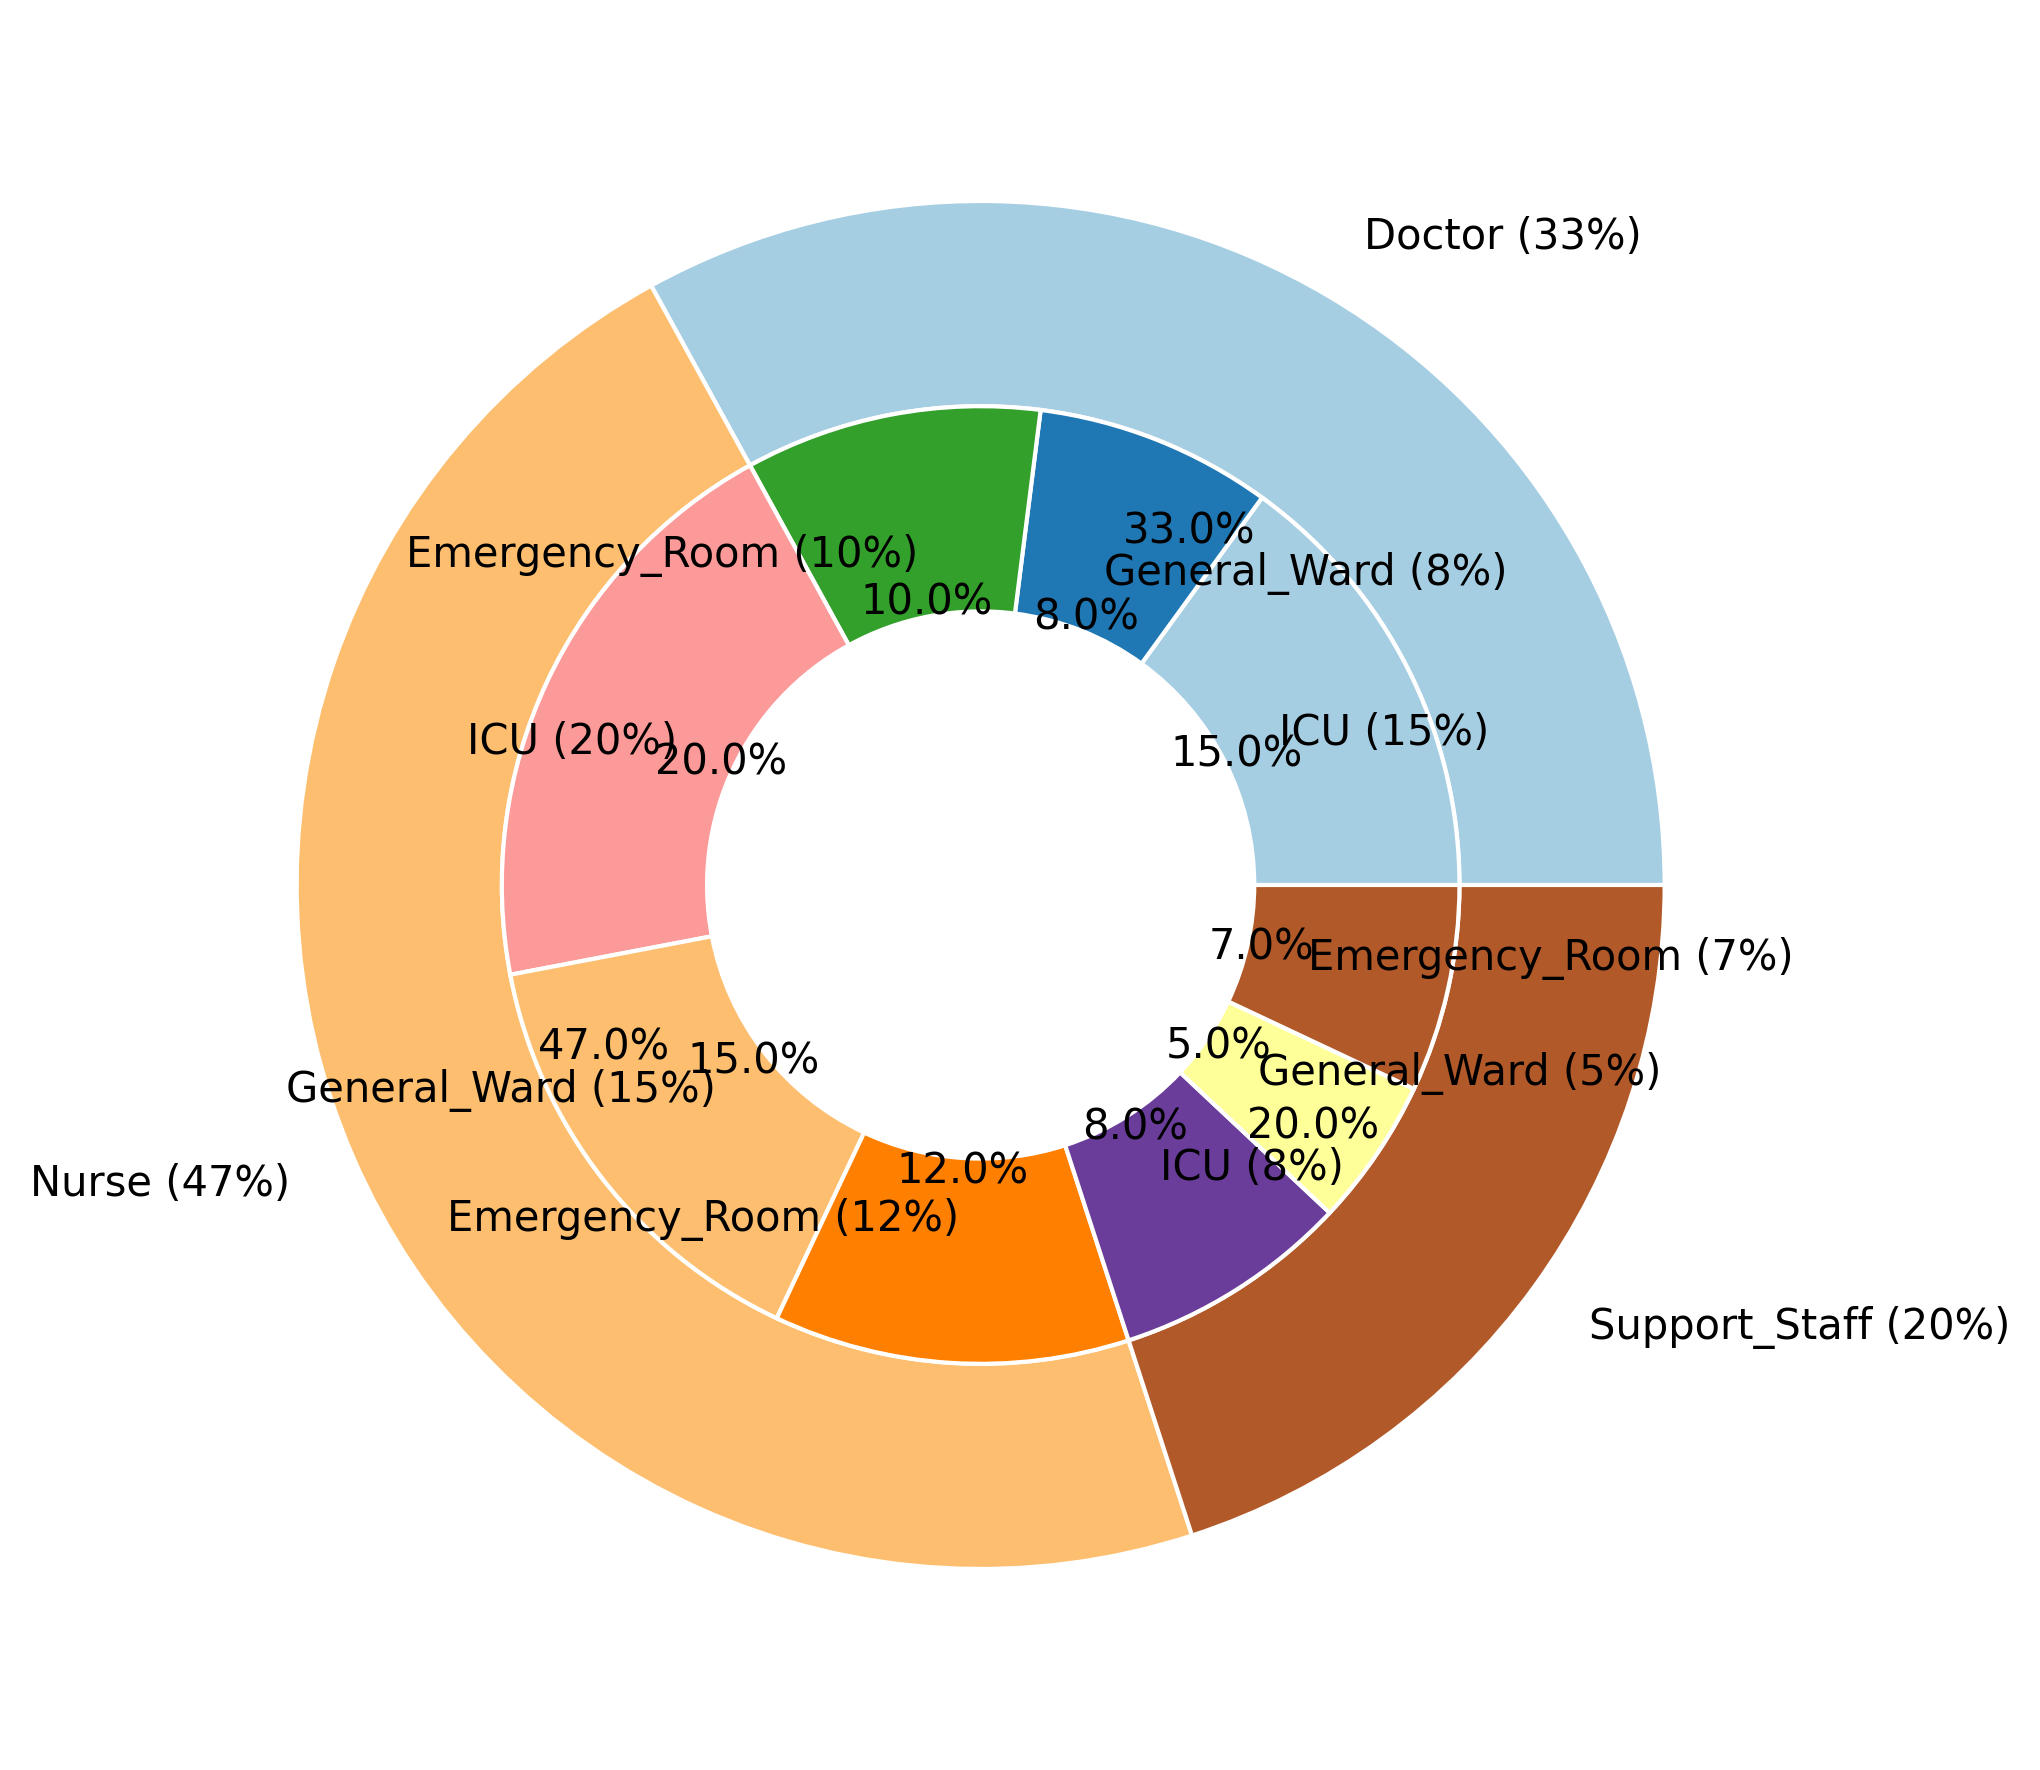What is the total infection rate percentage for doctors across all work environments? First, find the infection rates for doctors in each work environment: ICU (15%), General Ward (8%), and Emergency Room (10%). Summing these up gives 15 + 8 + 10 = 33%.
Answer: 33% Which group has the highest infection rate in the ICU? Compare the ICU infection rates: Doctor (15%), Nurse (20%), Support Staff (8%). Nurse has the highest percentage.
Answer: Nurse How does the infection rate for nurses in the Emergency Room compare to that of support staff in the ICU? Compare the infection rates: Nurse in Emergency Room (12%) and Support Staff in ICU (8%). 12% is higher than 8%.
Answer: Higher What is the ratio of the infection rate of nurses in the ICU to that in the General Ward? Nurse in ICU has an infection rate of 20% and in the General Ward it is 15%. The ratio is 20/15 = 4/3.
Answer: 4/3 Which role has the lowest total infection rate across all work environments? Calculate total infection rates: Doctors (33%), Nurses (47%), Support Staff (20%). Support Staff has the lowest total percentage.
Answer: Support Staff What is the difference in infection rate between doctors and nurses in the General Ward? Doctor infection rate in General Ward is 8%, and Nurse infection rate is 15%. The difference is 15% - 8% = 7%.
Answer: 7% What is the combined infection rate percentage for all roles in the Emergency Room? Sum the infection rates for all roles in the Emergency Room: Doctor (10%), Nurse (12%), Support Staff (7%). The total is 10 + 12 + 7 = 29%.
Answer: 29% How is the infection rate distributed among the different roles within the ICU visually presented? Visually, in the outer pie, the ICU section for each role is visible. Doctor (15%), Nurse (20%), and Support Staff (8%) segments can be identified with their relative sizes and colors. The largest segment in the inner pie is for nurses.
Answer: Nurse > Doctor > Support Staff If the total infection rate percentages for all roles in all environments is 100%, what percentage does the General Ward contribute alone? Sum the infection rates for all roles in the General Ward: Doctor (8%), Nurse (15%), Support Staff (5%). The total contribution from the General Ward is 8 + 15 + 5 = 28%.
Answer: 28% Among the support staff, which work environment has the lowest infection rate percentage? Compare the infection rates for support staff: ICU (8%), General Ward (5%), Emergency Room (7%). The General Ward has the lowest percentage.
Answer: General Ward 